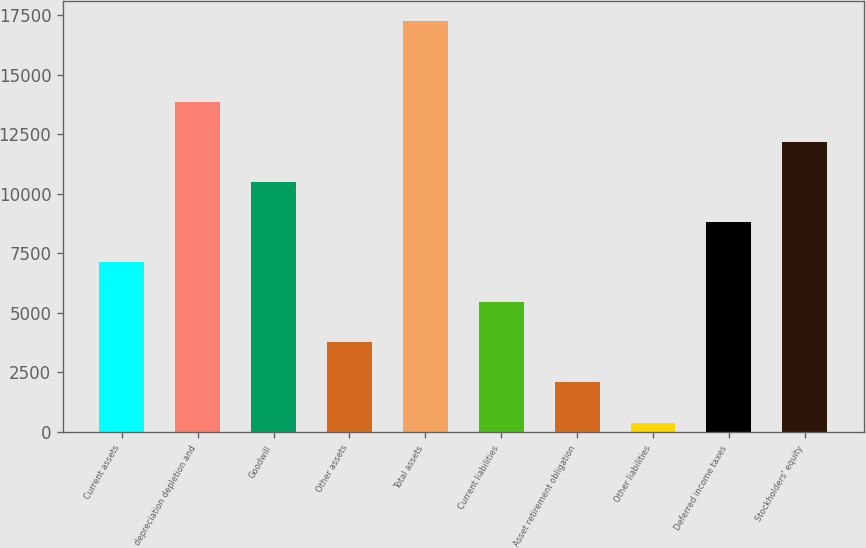<chart> <loc_0><loc_0><loc_500><loc_500><bar_chart><fcel>Current assets<fcel>depreciation depletion and<fcel>Goodwill<fcel>Other assets<fcel>Total assets<fcel>Current liabilities<fcel>Asset retirement obligation<fcel>Other liabilities<fcel>Deferred income taxes<fcel>Stockholders' equity<nl><fcel>7133.2<fcel>13866.4<fcel>10499.8<fcel>3766.6<fcel>17233<fcel>5449.9<fcel>2083.3<fcel>400<fcel>8816.5<fcel>12183.1<nl></chart> 